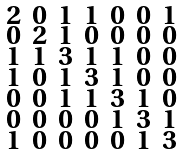Convert formula to latex. <formula><loc_0><loc_0><loc_500><loc_500>\begin{smallmatrix} 2 & 0 & 1 & 1 & 0 & 0 & 1 \\ 0 & 2 & 1 & 0 & 0 & 0 & 0 \\ 1 & 1 & 3 & 1 & 1 & 0 & 0 \\ 1 & 0 & 1 & 3 & 1 & 0 & 0 \\ 0 & 0 & 1 & 1 & 3 & 1 & 0 \\ 0 & 0 & 0 & 0 & 1 & 3 & 1 \\ 1 & 0 & 0 & 0 & 0 & 1 & 3 \end{smallmatrix}</formula> 